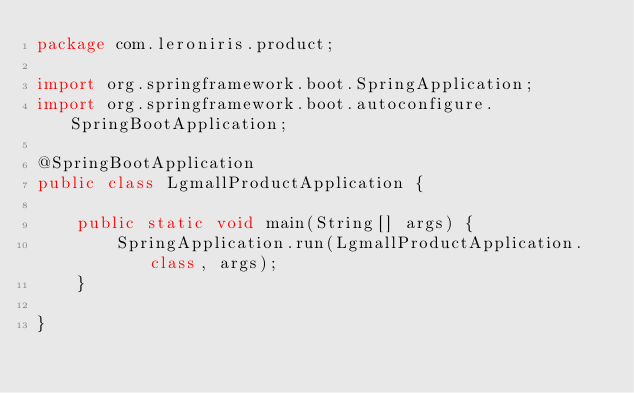<code> <loc_0><loc_0><loc_500><loc_500><_Java_>package com.leroniris.product;

import org.springframework.boot.SpringApplication;
import org.springframework.boot.autoconfigure.SpringBootApplication;

@SpringBootApplication
public class LgmallProductApplication {

    public static void main(String[] args) {
        SpringApplication.run(LgmallProductApplication.class, args);
    }

}
</code> 